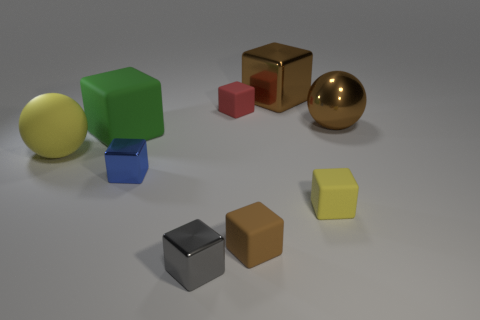Subtract all small blue metal blocks. How many blocks are left? 6 Subtract all yellow blocks. How many blocks are left? 6 Subtract 2 spheres. How many spheres are left? 0 Subtract 0 green cylinders. How many objects are left? 9 Subtract all blocks. How many objects are left? 2 Subtract all brown cubes. Subtract all brown cylinders. How many cubes are left? 5 Subtract all brown blocks. How many green balls are left? 0 Subtract all rubber blocks. Subtract all gray shiny things. How many objects are left? 4 Add 5 tiny gray shiny things. How many tiny gray shiny things are left? 6 Add 1 big yellow rubber spheres. How many big yellow rubber spheres exist? 2 